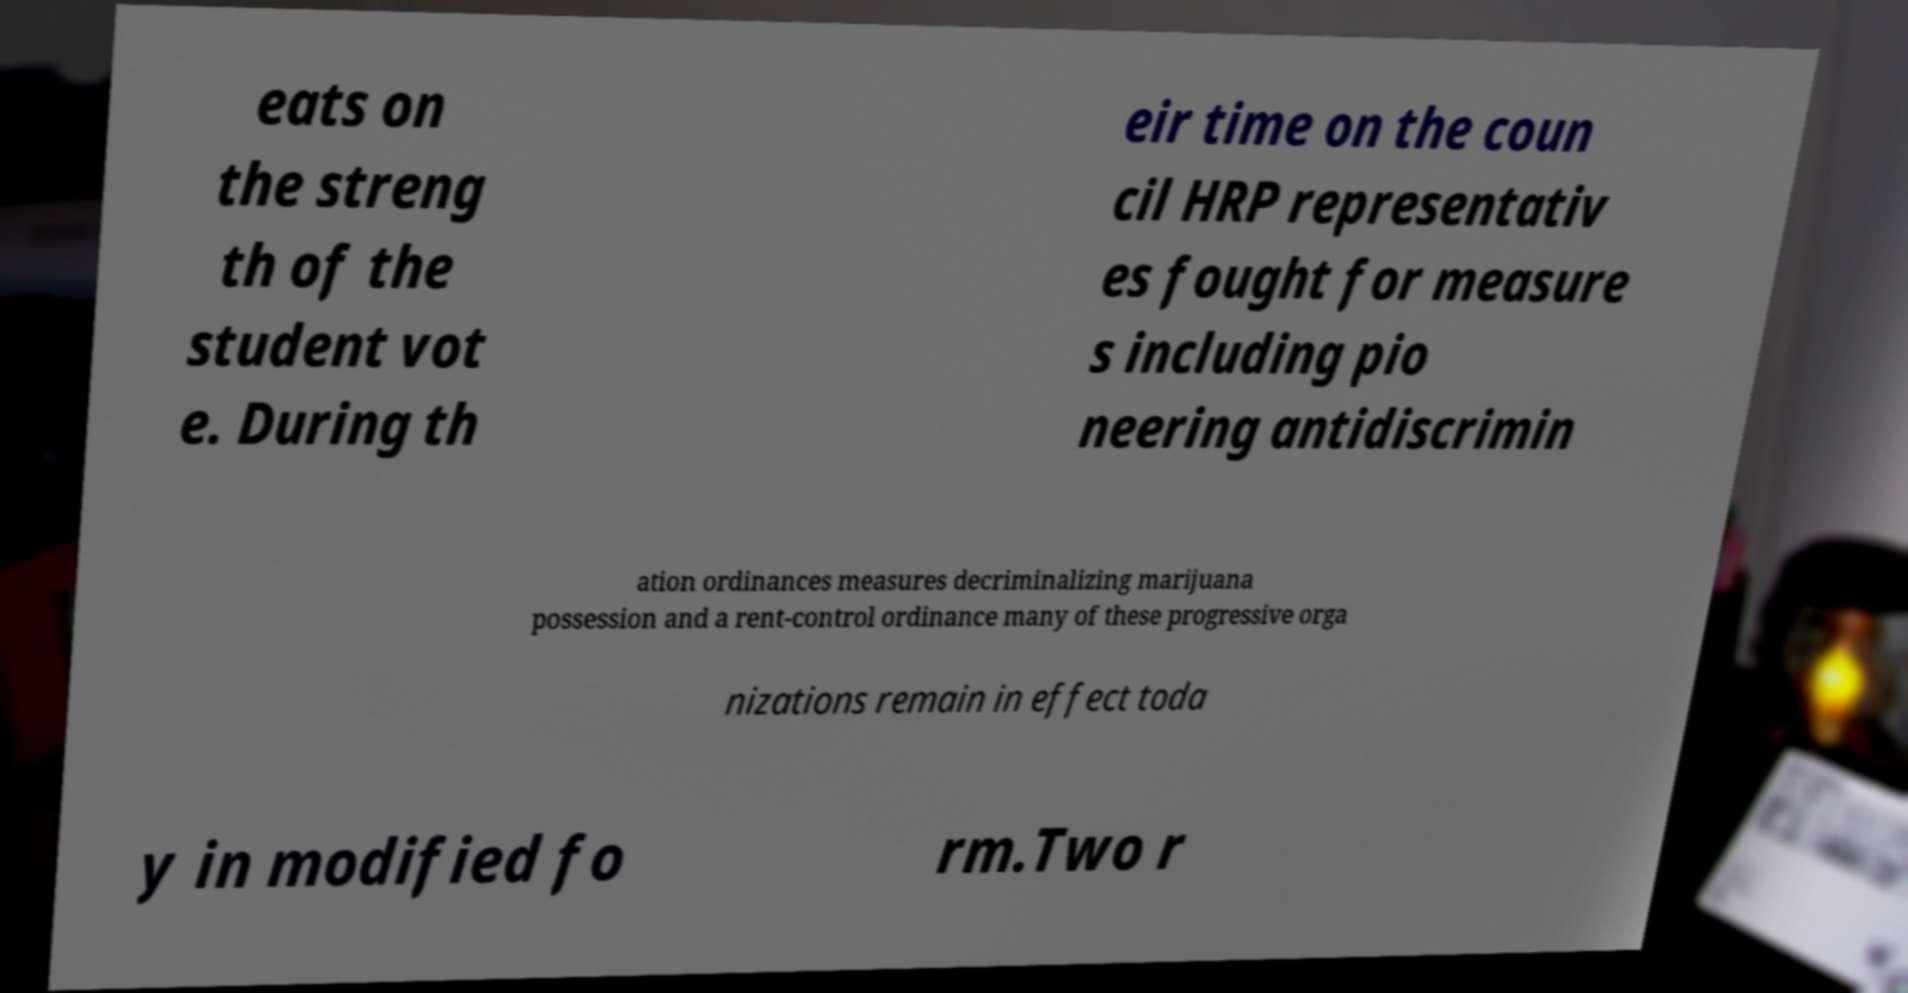Can you accurately transcribe the text from the provided image for me? eats on the streng th of the student vot e. During th eir time on the coun cil HRP representativ es fought for measure s including pio neering antidiscrimin ation ordinances measures decriminalizing marijuana possession and a rent-control ordinance many of these progressive orga nizations remain in effect toda y in modified fo rm.Two r 